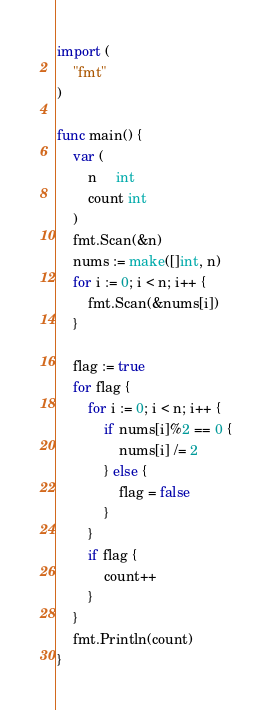<code> <loc_0><loc_0><loc_500><loc_500><_Go_>import (
    "fmt"
)

func main() {
    var (
        n     int
        count int
    )
    fmt.Scan(&n)
    nums := make([]int, n)
    for i := 0; i < n; i++ {
        fmt.Scan(&nums[i])
    }

    flag := true
    for flag {
        for i := 0; i < n; i++ {
            if nums[i]%2 == 0 {
                nums[i] /= 2
            } else {
                flag = false
            }
        }
        if flag {
            count++
        }
    }
    fmt.Println(count)
}</code> 